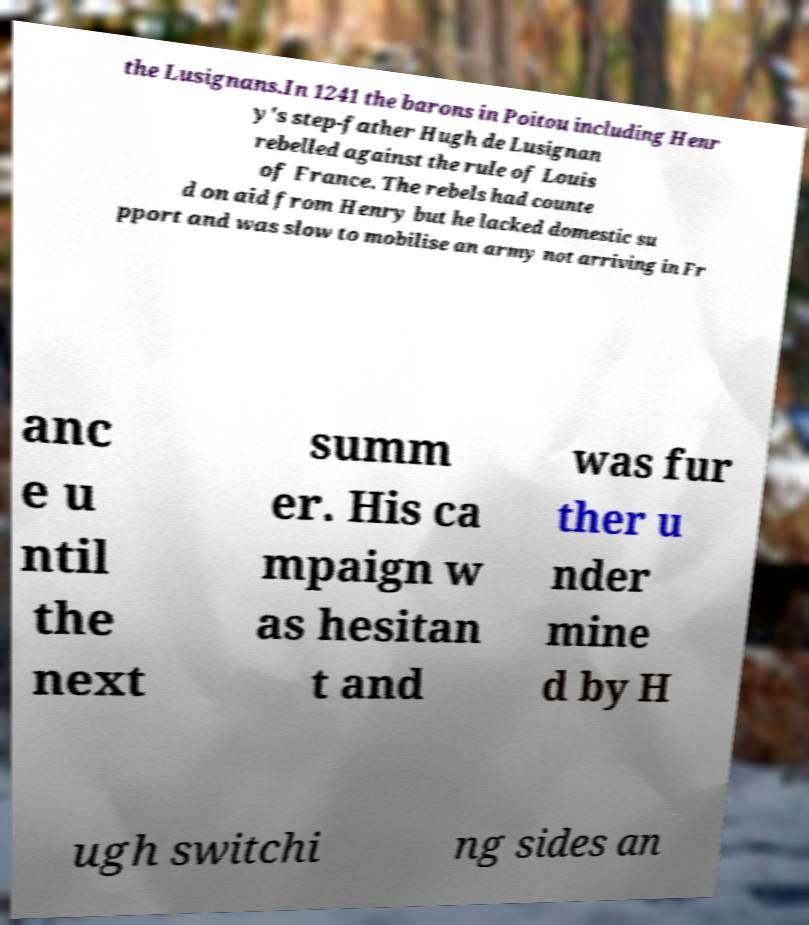Please read and relay the text visible in this image. What does it say? the Lusignans.In 1241 the barons in Poitou including Henr y's step-father Hugh de Lusignan rebelled against the rule of Louis of France. The rebels had counte d on aid from Henry but he lacked domestic su pport and was slow to mobilise an army not arriving in Fr anc e u ntil the next summ er. His ca mpaign w as hesitan t and was fur ther u nder mine d by H ugh switchi ng sides an 